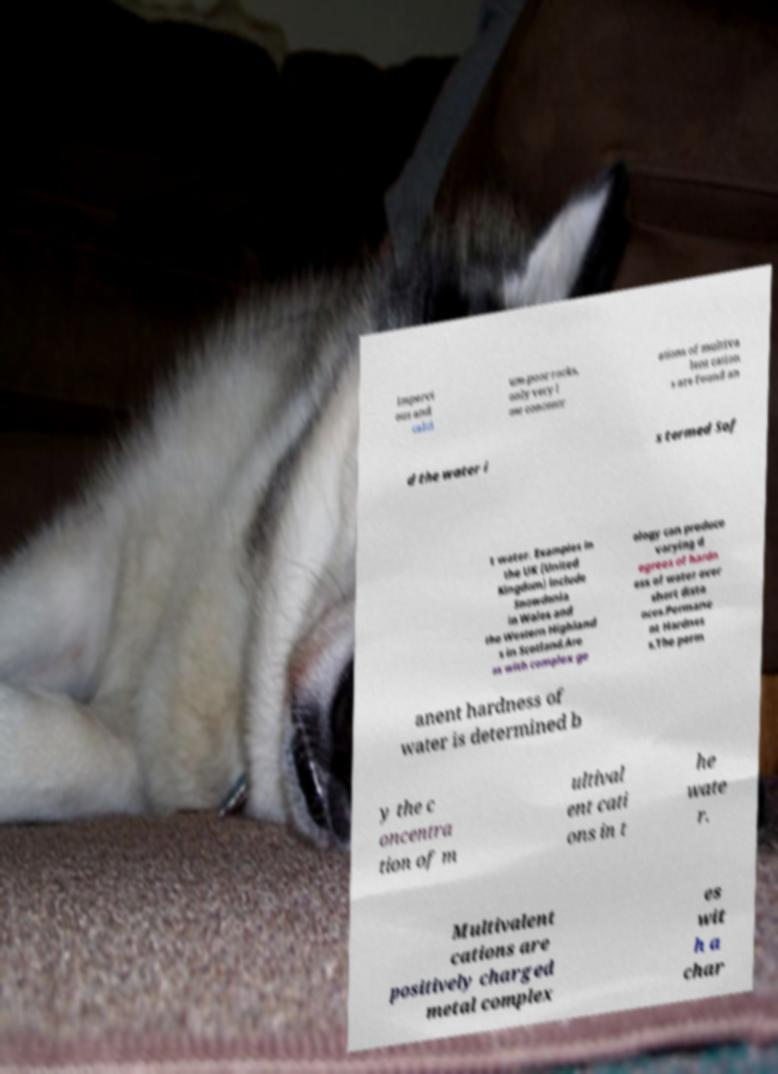Please read and relay the text visible in this image. What does it say? impervi ous and calci um-poor rocks, only very l ow concentr ations of multiva lent cation s are found an d the water i s termed Sof t water. Examples in the UK (United Kingdom) include Snowdonia in Wales and the Western Highland s in Scotland.Are as with complex ge ology can produce varying d egrees of hardn ess of water over short dista nces.Permane nt Hardnes s.The perm anent hardness of water is determined b y the c oncentra tion of m ultival ent cati ons in t he wate r. Multivalent cations are positively charged metal complex es wit h a char 